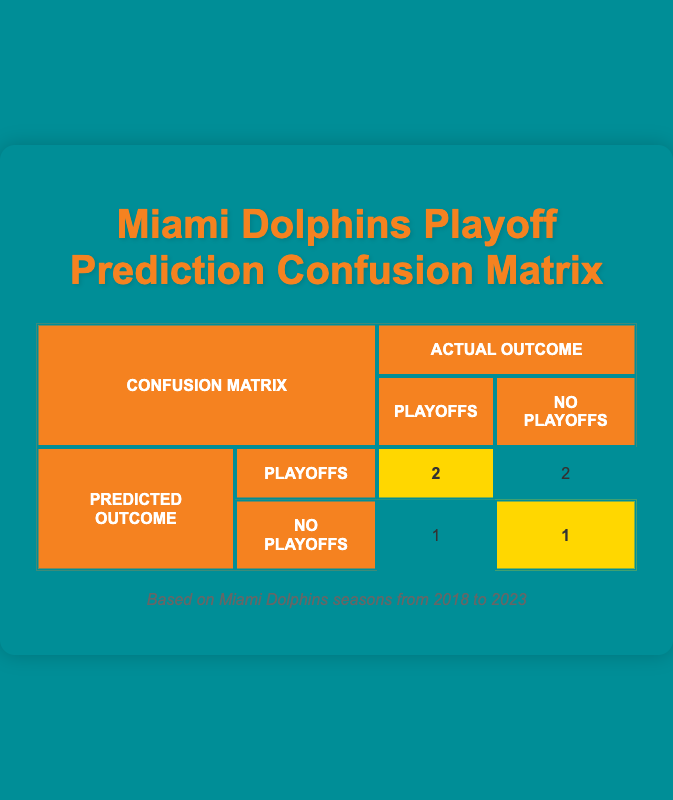What is the total number of seasons predicted for the Playoffs? There are two rows that indicate "Playoffs" under the "Predicted Outcome" category: the seasons 2018 and 2022. Thus, the total count is 2.
Answer: 2 How many times did the predictions match the actual outcomes? The predictions match the actual outcomes in the years 2019, 2022, and 2023. By looking at these rows, we can see that both predicted and actual outcomes align in these cases. Therefore, the total count is 3.
Answer: 3 What is the number of predictions for "No Playoffs" that turned out to be "Playoffs"? There is only one instance where "No Playoffs" was predicted, and the actual outcome was "Playoffs", which occurred in 2020. So, the total count is 1.
Answer: 1 In how many seasons did the Miami Dolphins actually make the Playoffs? According to the matrix, the seasons in which the Miami Dolphins actually made the Playoffs are 2020, 2022, and 2023, which accounts for 3 seasons.
Answer: 3 Is there any season where the Miami Dolphins were predicted to make the Playoffs but did not? Yes, this occurred in the season 2018 when they were predicted for the Playoffs but actually did not qualify.
Answer: Yes How many total outcomes were recorded in the table? The table contains 6 rows, corresponding to the 6 seasons from 2018 through 2023, indicating the predictions and actual outcomes. Thus, the total outcomes recorded are 6.
Answer: 6 What percentage of predicted outcomes were correct? To determine the percentage, we identify the correct predictions (3) out of the total predictions (6). The calculation is (3/6) * 100, which results in 50%.
Answer: 50% In which season did the Miami Dolphins have a correct prediction of making the playoffs? The Miami Dolphins had correct predictions of making the playoffs in the seasons 2022 and 2023. Both these instances show a match between predicted and actual outcomes.
Answer: 2022 and 2023 